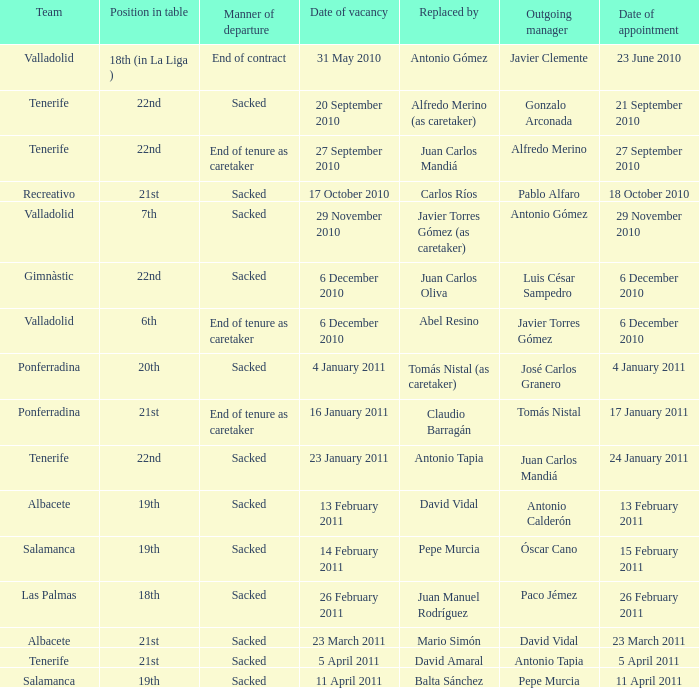What was the manner of departure for the appointment date of 21 september 2010 Sacked. 